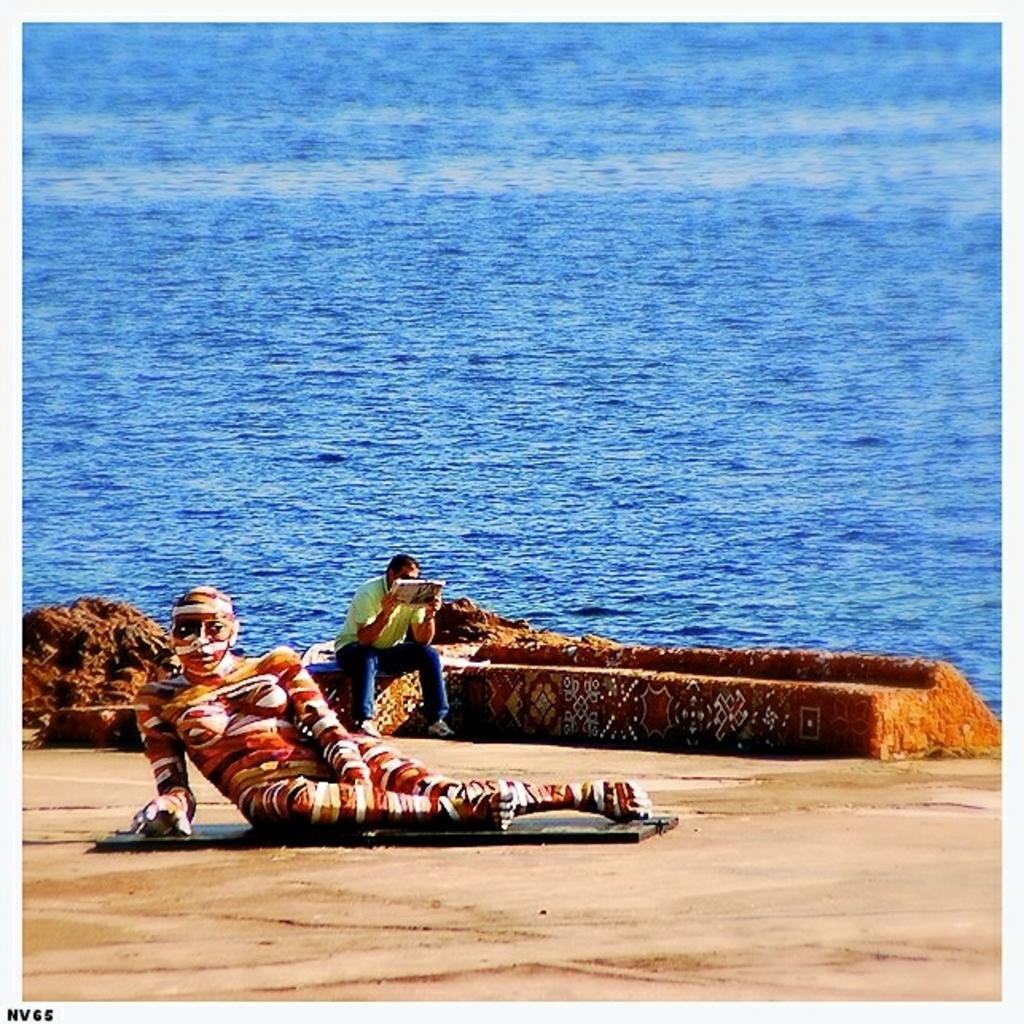What is the main subject in the foreground of the image? There is a person laid down on the ground in the foreground of the image. What is the person in the background of the image doing? There is a person reading a book in the background of the image. What can be seen in the image besides the people? There is water visible in the image. What type of parcel is being delivered to the person's throat in the image? There is no parcel or throat mentioned in the image; it only features a person laid down on the ground and another person reading a book. 